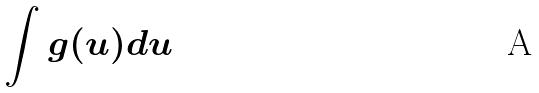<formula> <loc_0><loc_0><loc_500><loc_500>\int g ( u ) d u</formula> 